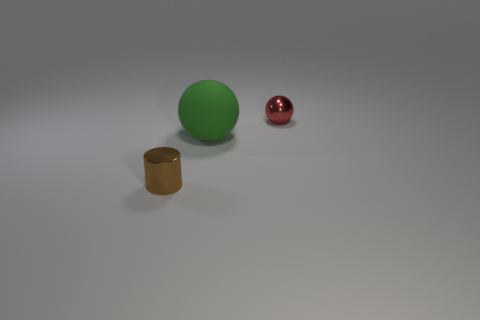Add 3 tiny green metallic cubes. How many objects exist? 6 Subtract all balls. How many objects are left? 1 Add 1 tiny green metallic balls. How many tiny green metallic balls exist? 1 Subtract 0 blue cylinders. How many objects are left? 3 Subtract all yellow balls. Subtract all cyan cylinders. How many balls are left? 2 Subtract all tiny green cylinders. Subtract all big matte objects. How many objects are left? 2 Add 1 tiny shiny balls. How many tiny shiny balls are left? 2 